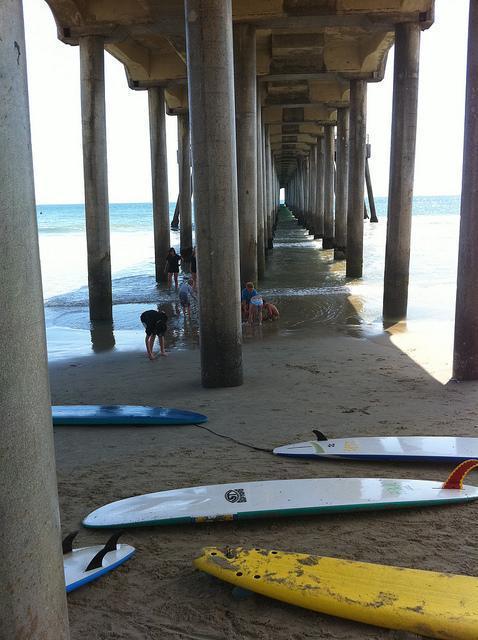What colour is the board on the bottom right?
Select the accurate response from the four choices given to answer the question.
Options: Green, red, yellow, orange. Yellow. 